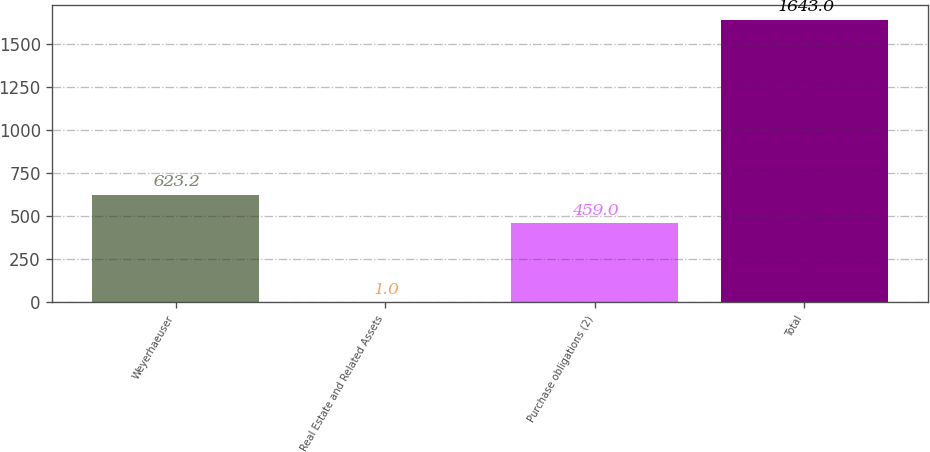Convert chart to OTSL. <chart><loc_0><loc_0><loc_500><loc_500><bar_chart><fcel>Weyerhaeuser<fcel>Real Estate and Related Assets<fcel>Purchase obligations (2)<fcel>Total<nl><fcel>623.2<fcel>1<fcel>459<fcel>1643<nl></chart> 